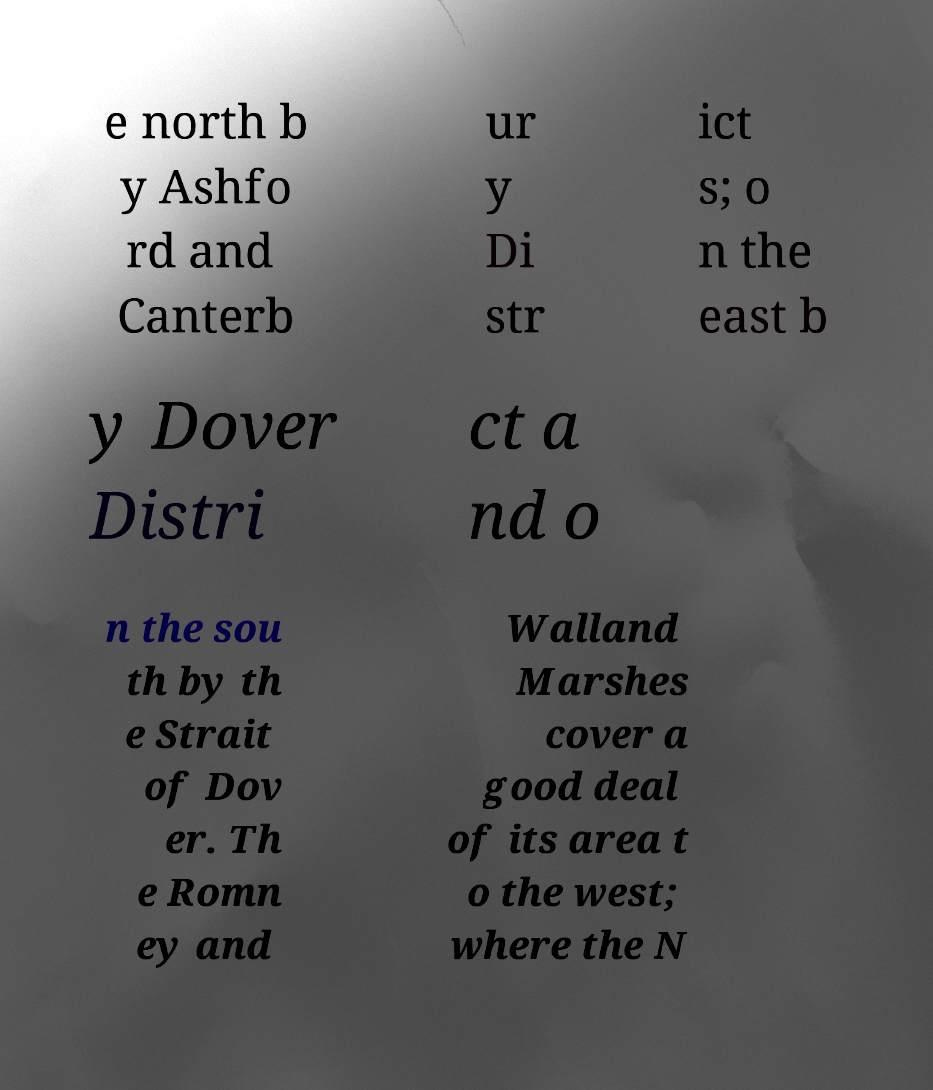There's text embedded in this image that I need extracted. Can you transcribe it verbatim? e north b y Ashfo rd and Canterb ur y Di str ict s; o n the east b y Dover Distri ct a nd o n the sou th by th e Strait of Dov er. Th e Romn ey and Walland Marshes cover a good deal of its area t o the west; where the N 